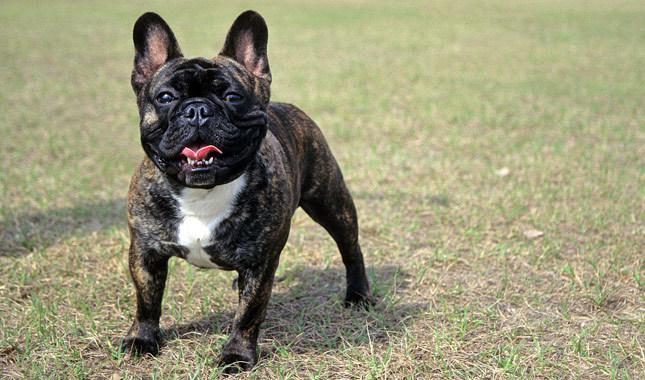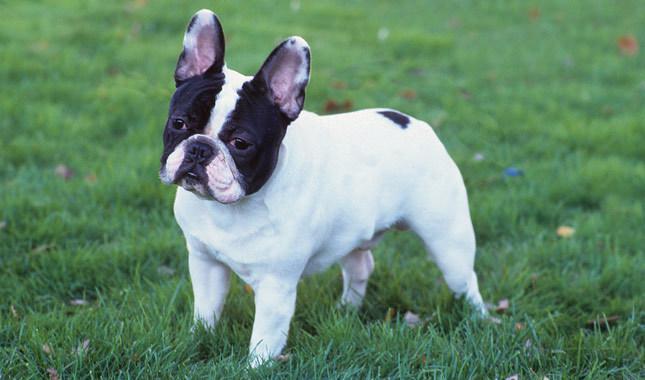The first image is the image on the left, the second image is the image on the right. Given the left and right images, does the statement "There is atleast one white, pied french bulldog." hold true? Answer yes or no. Yes. The first image is the image on the left, the second image is the image on the right. Evaluate the accuracy of this statement regarding the images: "At least one dog is wearing a red collar.". Is it true? Answer yes or no. No. 